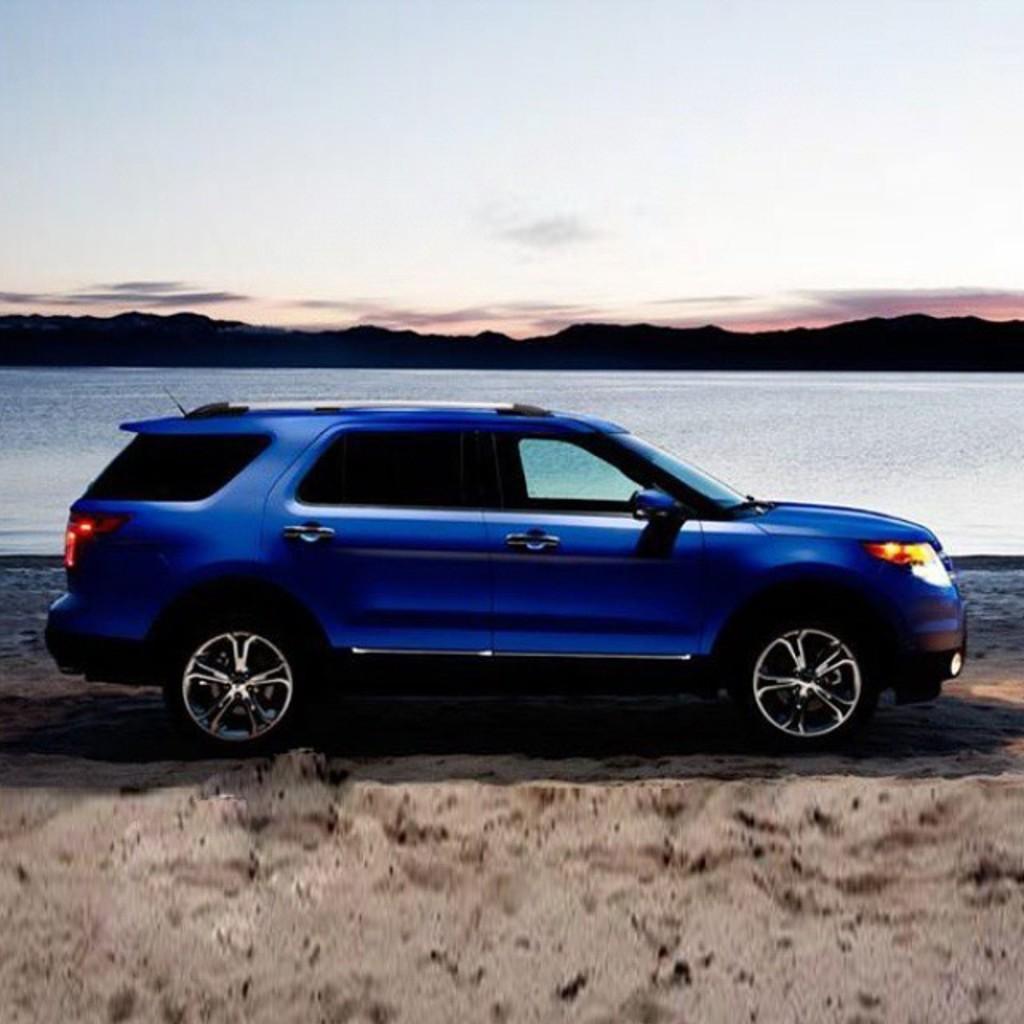Please provide a concise description of this image. In this image in the center there is one car, at the bottom there is sand and in the background there is a river, mountains and a walkway. At the top there is sky. 